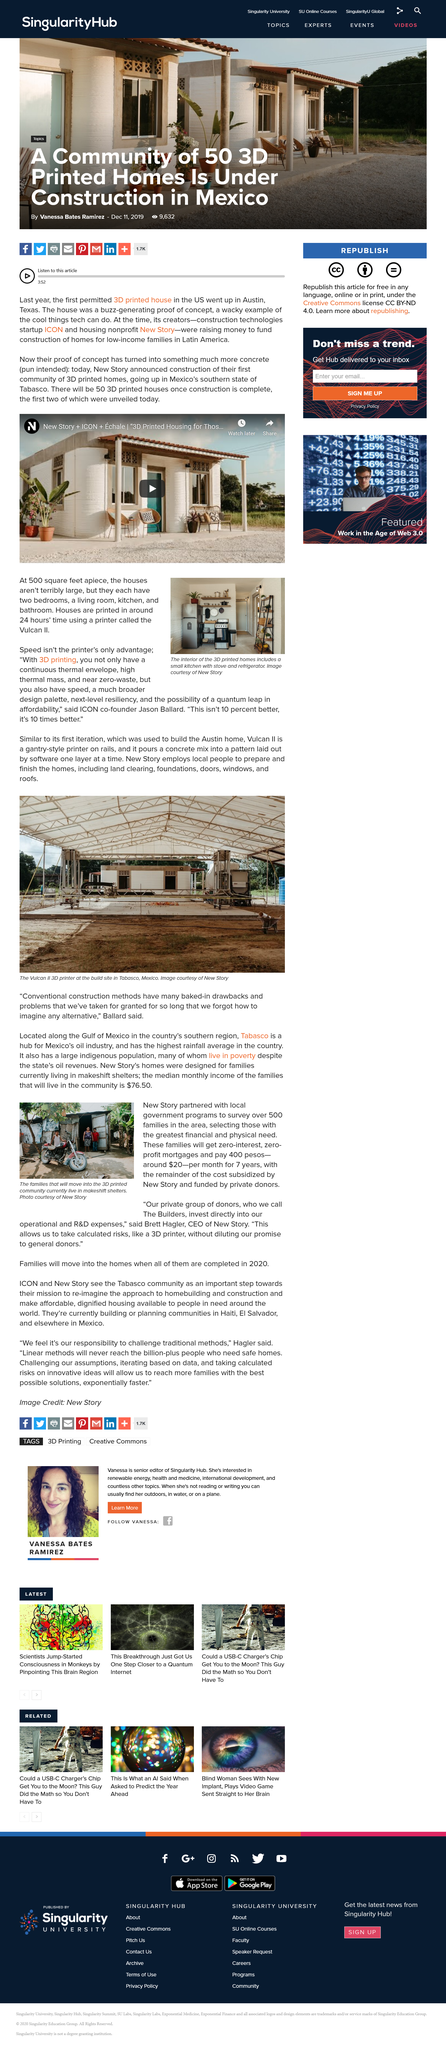Identify some key points in this picture. It takes 24 hours to print each house. In Tabasco, 50 3D houses will be constructed. In Austin, Texas, the first permitted 3D printed houses were constructed, marking a milestone in the integration of 3D printing technology into the realm of residential construction. The kitchen is equipped with a stove and a refrigerator. The houses have two bedrooms. 